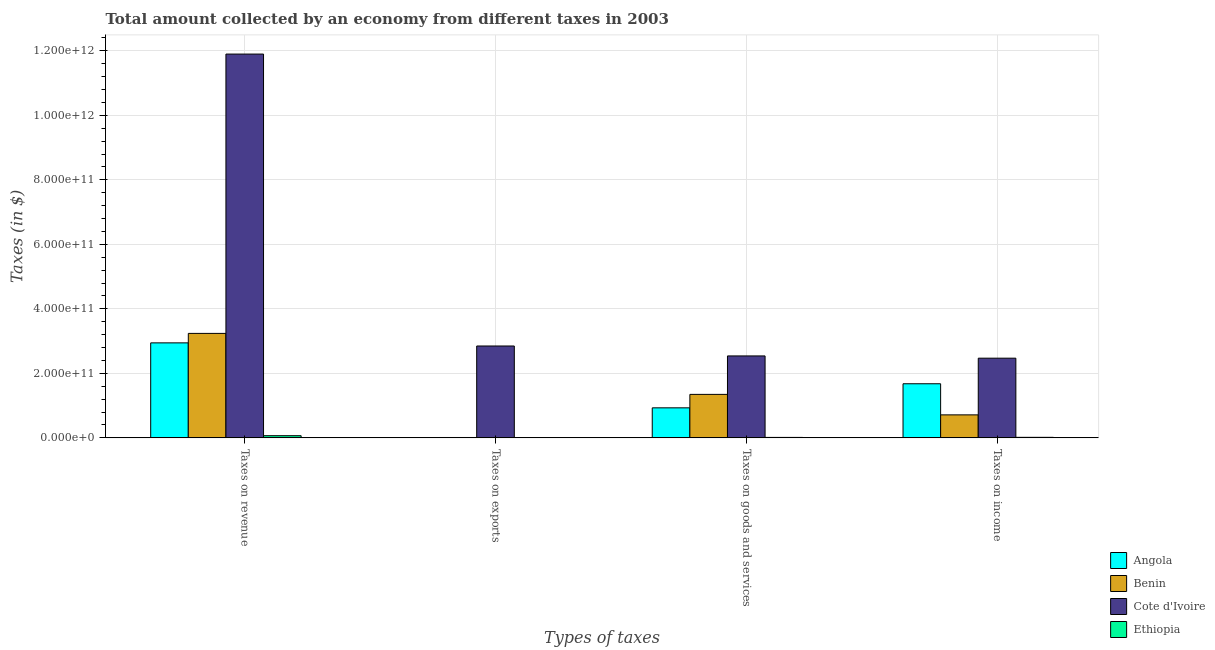Are the number of bars per tick equal to the number of legend labels?
Offer a very short reply. Yes. What is the label of the 3rd group of bars from the left?
Provide a short and direct response. Taxes on goods and services. What is the amount collected as tax on income in Angola?
Provide a succinct answer. 1.68e+11. Across all countries, what is the maximum amount collected as tax on exports?
Offer a terse response. 2.85e+11. Across all countries, what is the minimum amount collected as tax on income?
Offer a very short reply. 1.66e+09. In which country was the amount collected as tax on income maximum?
Provide a succinct answer. Cote d'Ivoire. In which country was the amount collected as tax on revenue minimum?
Keep it short and to the point. Ethiopia. What is the total amount collected as tax on goods in the graph?
Offer a terse response. 4.83e+11. What is the difference between the amount collected as tax on revenue in Angola and that in Cote d'Ivoire?
Give a very brief answer. -8.96e+11. What is the difference between the amount collected as tax on goods in Benin and the amount collected as tax on income in Cote d'Ivoire?
Make the answer very short. -1.12e+11. What is the average amount collected as tax on income per country?
Your answer should be very brief. 1.22e+11. What is the difference between the amount collected as tax on goods and amount collected as tax on income in Angola?
Offer a terse response. -7.46e+1. What is the ratio of the amount collected as tax on revenue in Benin to that in Ethiopia?
Provide a short and direct response. 48.02. Is the difference between the amount collected as tax on income in Cote d'Ivoire and Benin greater than the difference between the amount collected as tax on exports in Cote d'Ivoire and Benin?
Offer a very short reply. No. What is the difference between the highest and the second highest amount collected as tax on goods?
Make the answer very short. 1.19e+11. What is the difference between the highest and the lowest amount collected as tax on income?
Keep it short and to the point. 2.45e+11. In how many countries, is the amount collected as tax on exports greater than the average amount collected as tax on exports taken over all countries?
Your response must be concise. 1. Is it the case that in every country, the sum of the amount collected as tax on income and amount collected as tax on exports is greater than the sum of amount collected as tax on goods and amount collected as tax on revenue?
Offer a terse response. No. What does the 1st bar from the left in Taxes on goods and services represents?
Ensure brevity in your answer.  Angola. What does the 4th bar from the right in Taxes on income represents?
Provide a succinct answer. Angola. Is it the case that in every country, the sum of the amount collected as tax on revenue and amount collected as tax on exports is greater than the amount collected as tax on goods?
Ensure brevity in your answer.  Yes. How many bars are there?
Offer a terse response. 16. How many countries are there in the graph?
Make the answer very short. 4. What is the difference between two consecutive major ticks on the Y-axis?
Your response must be concise. 2.00e+11. Are the values on the major ticks of Y-axis written in scientific E-notation?
Provide a succinct answer. Yes. Does the graph contain grids?
Your response must be concise. Yes. Where does the legend appear in the graph?
Offer a very short reply. Bottom right. How are the legend labels stacked?
Give a very brief answer. Vertical. What is the title of the graph?
Your answer should be very brief. Total amount collected by an economy from different taxes in 2003. Does "Liberia" appear as one of the legend labels in the graph?
Offer a terse response. No. What is the label or title of the X-axis?
Your response must be concise. Types of taxes. What is the label or title of the Y-axis?
Your answer should be very brief. Taxes (in $). What is the Taxes (in $) of Angola in Taxes on revenue?
Make the answer very short. 2.95e+11. What is the Taxes (in $) of Benin in Taxes on revenue?
Offer a very short reply. 3.24e+11. What is the Taxes (in $) in Cote d'Ivoire in Taxes on revenue?
Your answer should be compact. 1.19e+12. What is the Taxes (in $) in Ethiopia in Taxes on revenue?
Provide a succinct answer. 6.75e+09. What is the Taxes (in $) of Angola in Taxes on exports?
Offer a terse response. 4.24e+08. What is the Taxes (in $) of Benin in Taxes on exports?
Keep it short and to the point. 1.17e+09. What is the Taxes (in $) in Cote d'Ivoire in Taxes on exports?
Offer a very short reply. 2.85e+11. What is the Taxes (in $) of Ethiopia in Taxes on exports?
Give a very brief answer. 1.10e+06. What is the Taxes (in $) of Angola in Taxes on goods and services?
Your response must be concise. 9.31e+1. What is the Taxes (in $) in Benin in Taxes on goods and services?
Your answer should be very brief. 1.35e+11. What is the Taxes (in $) of Cote d'Ivoire in Taxes on goods and services?
Make the answer very short. 2.54e+11. What is the Taxes (in $) in Ethiopia in Taxes on goods and services?
Ensure brevity in your answer.  1.40e+09. What is the Taxes (in $) of Angola in Taxes on income?
Give a very brief answer. 1.68e+11. What is the Taxes (in $) of Benin in Taxes on income?
Keep it short and to the point. 7.13e+1. What is the Taxes (in $) in Cote d'Ivoire in Taxes on income?
Your answer should be compact. 2.47e+11. What is the Taxes (in $) of Ethiopia in Taxes on income?
Provide a succinct answer. 1.66e+09. Across all Types of taxes, what is the maximum Taxes (in $) of Angola?
Your response must be concise. 2.95e+11. Across all Types of taxes, what is the maximum Taxes (in $) in Benin?
Ensure brevity in your answer.  3.24e+11. Across all Types of taxes, what is the maximum Taxes (in $) of Cote d'Ivoire?
Make the answer very short. 1.19e+12. Across all Types of taxes, what is the maximum Taxes (in $) of Ethiopia?
Give a very brief answer. 6.75e+09. Across all Types of taxes, what is the minimum Taxes (in $) of Angola?
Provide a succinct answer. 4.24e+08. Across all Types of taxes, what is the minimum Taxes (in $) of Benin?
Provide a succinct answer. 1.17e+09. Across all Types of taxes, what is the minimum Taxes (in $) of Cote d'Ivoire?
Provide a short and direct response. 2.47e+11. Across all Types of taxes, what is the minimum Taxes (in $) in Ethiopia?
Give a very brief answer. 1.10e+06. What is the total Taxes (in $) in Angola in the graph?
Your answer should be compact. 5.56e+11. What is the total Taxes (in $) of Benin in the graph?
Give a very brief answer. 5.31e+11. What is the total Taxes (in $) of Cote d'Ivoire in the graph?
Make the answer very short. 1.98e+12. What is the total Taxes (in $) in Ethiopia in the graph?
Offer a very short reply. 9.81e+09. What is the difference between the Taxes (in $) of Angola in Taxes on revenue and that in Taxes on exports?
Give a very brief answer. 2.94e+11. What is the difference between the Taxes (in $) of Benin in Taxes on revenue and that in Taxes on exports?
Your answer should be very brief. 3.23e+11. What is the difference between the Taxes (in $) in Cote d'Ivoire in Taxes on revenue and that in Taxes on exports?
Offer a very short reply. 9.05e+11. What is the difference between the Taxes (in $) in Ethiopia in Taxes on revenue and that in Taxes on exports?
Provide a succinct answer. 6.74e+09. What is the difference between the Taxes (in $) in Angola in Taxes on revenue and that in Taxes on goods and services?
Keep it short and to the point. 2.01e+11. What is the difference between the Taxes (in $) in Benin in Taxes on revenue and that in Taxes on goods and services?
Offer a very short reply. 1.89e+11. What is the difference between the Taxes (in $) in Cote d'Ivoire in Taxes on revenue and that in Taxes on goods and services?
Your answer should be compact. 9.36e+11. What is the difference between the Taxes (in $) in Ethiopia in Taxes on revenue and that in Taxes on goods and services?
Give a very brief answer. 5.35e+09. What is the difference between the Taxes (in $) in Angola in Taxes on revenue and that in Taxes on income?
Ensure brevity in your answer.  1.27e+11. What is the difference between the Taxes (in $) of Benin in Taxes on revenue and that in Taxes on income?
Your answer should be very brief. 2.53e+11. What is the difference between the Taxes (in $) of Cote d'Ivoire in Taxes on revenue and that in Taxes on income?
Your answer should be compact. 9.43e+11. What is the difference between the Taxes (in $) in Ethiopia in Taxes on revenue and that in Taxes on income?
Give a very brief answer. 5.08e+09. What is the difference between the Taxes (in $) in Angola in Taxes on exports and that in Taxes on goods and services?
Provide a succinct answer. -9.27e+1. What is the difference between the Taxes (in $) in Benin in Taxes on exports and that in Taxes on goods and services?
Keep it short and to the point. -1.34e+11. What is the difference between the Taxes (in $) of Cote d'Ivoire in Taxes on exports and that in Taxes on goods and services?
Your answer should be compact. 3.08e+1. What is the difference between the Taxes (in $) in Ethiopia in Taxes on exports and that in Taxes on goods and services?
Provide a short and direct response. -1.40e+09. What is the difference between the Taxes (in $) in Angola in Taxes on exports and that in Taxes on income?
Your response must be concise. -1.67e+11. What is the difference between the Taxes (in $) in Benin in Taxes on exports and that in Taxes on income?
Give a very brief answer. -7.01e+1. What is the difference between the Taxes (in $) of Cote d'Ivoire in Taxes on exports and that in Taxes on income?
Keep it short and to the point. 3.78e+1. What is the difference between the Taxes (in $) of Ethiopia in Taxes on exports and that in Taxes on income?
Make the answer very short. -1.66e+09. What is the difference between the Taxes (in $) in Angola in Taxes on goods and services and that in Taxes on income?
Ensure brevity in your answer.  -7.46e+1. What is the difference between the Taxes (in $) in Benin in Taxes on goods and services and that in Taxes on income?
Give a very brief answer. 6.35e+1. What is the difference between the Taxes (in $) of Cote d'Ivoire in Taxes on goods and services and that in Taxes on income?
Give a very brief answer. 7.00e+09. What is the difference between the Taxes (in $) of Ethiopia in Taxes on goods and services and that in Taxes on income?
Provide a short and direct response. -2.65e+08. What is the difference between the Taxes (in $) of Angola in Taxes on revenue and the Taxes (in $) of Benin in Taxes on exports?
Offer a terse response. 2.93e+11. What is the difference between the Taxes (in $) of Angola in Taxes on revenue and the Taxes (in $) of Cote d'Ivoire in Taxes on exports?
Make the answer very short. 9.69e+09. What is the difference between the Taxes (in $) in Angola in Taxes on revenue and the Taxes (in $) in Ethiopia in Taxes on exports?
Provide a succinct answer. 2.95e+11. What is the difference between the Taxes (in $) in Benin in Taxes on revenue and the Taxes (in $) in Cote d'Ivoire in Taxes on exports?
Your answer should be very brief. 3.90e+1. What is the difference between the Taxes (in $) of Benin in Taxes on revenue and the Taxes (in $) of Ethiopia in Taxes on exports?
Offer a terse response. 3.24e+11. What is the difference between the Taxes (in $) of Cote d'Ivoire in Taxes on revenue and the Taxes (in $) of Ethiopia in Taxes on exports?
Your response must be concise. 1.19e+12. What is the difference between the Taxes (in $) in Angola in Taxes on revenue and the Taxes (in $) in Benin in Taxes on goods and services?
Provide a short and direct response. 1.60e+11. What is the difference between the Taxes (in $) of Angola in Taxes on revenue and the Taxes (in $) of Cote d'Ivoire in Taxes on goods and services?
Your response must be concise. 4.05e+1. What is the difference between the Taxes (in $) in Angola in Taxes on revenue and the Taxes (in $) in Ethiopia in Taxes on goods and services?
Provide a short and direct response. 2.93e+11. What is the difference between the Taxes (in $) of Benin in Taxes on revenue and the Taxes (in $) of Cote d'Ivoire in Taxes on goods and services?
Give a very brief answer. 6.98e+1. What is the difference between the Taxes (in $) of Benin in Taxes on revenue and the Taxes (in $) of Ethiopia in Taxes on goods and services?
Provide a short and direct response. 3.23e+11. What is the difference between the Taxes (in $) in Cote d'Ivoire in Taxes on revenue and the Taxes (in $) in Ethiopia in Taxes on goods and services?
Offer a terse response. 1.19e+12. What is the difference between the Taxes (in $) in Angola in Taxes on revenue and the Taxes (in $) in Benin in Taxes on income?
Ensure brevity in your answer.  2.23e+11. What is the difference between the Taxes (in $) in Angola in Taxes on revenue and the Taxes (in $) in Cote d'Ivoire in Taxes on income?
Make the answer very short. 4.75e+1. What is the difference between the Taxes (in $) in Angola in Taxes on revenue and the Taxes (in $) in Ethiopia in Taxes on income?
Offer a very short reply. 2.93e+11. What is the difference between the Taxes (in $) in Benin in Taxes on revenue and the Taxes (in $) in Cote d'Ivoire in Taxes on income?
Provide a short and direct response. 7.68e+1. What is the difference between the Taxes (in $) of Benin in Taxes on revenue and the Taxes (in $) of Ethiopia in Taxes on income?
Provide a succinct answer. 3.22e+11. What is the difference between the Taxes (in $) of Cote d'Ivoire in Taxes on revenue and the Taxes (in $) of Ethiopia in Taxes on income?
Offer a very short reply. 1.19e+12. What is the difference between the Taxes (in $) in Angola in Taxes on exports and the Taxes (in $) in Benin in Taxes on goods and services?
Offer a terse response. -1.34e+11. What is the difference between the Taxes (in $) of Angola in Taxes on exports and the Taxes (in $) of Cote d'Ivoire in Taxes on goods and services?
Provide a succinct answer. -2.54e+11. What is the difference between the Taxes (in $) of Angola in Taxes on exports and the Taxes (in $) of Ethiopia in Taxes on goods and services?
Ensure brevity in your answer.  -9.74e+08. What is the difference between the Taxes (in $) of Benin in Taxes on exports and the Taxes (in $) of Cote d'Ivoire in Taxes on goods and services?
Ensure brevity in your answer.  -2.53e+11. What is the difference between the Taxes (in $) of Benin in Taxes on exports and the Taxes (in $) of Ethiopia in Taxes on goods and services?
Offer a terse response. -2.24e+08. What is the difference between the Taxes (in $) of Cote d'Ivoire in Taxes on exports and the Taxes (in $) of Ethiopia in Taxes on goods and services?
Your response must be concise. 2.84e+11. What is the difference between the Taxes (in $) in Angola in Taxes on exports and the Taxes (in $) in Benin in Taxes on income?
Your answer should be very brief. -7.09e+1. What is the difference between the Taxes (in $) in Angola in Taxes on exports and the Taxes (in $) in Cote d'Ivoire in Taxes on income?
Provide a short and direct response. -2.47e+11. What is the difference between the Taxes (in $) of Angola in Taxes on exports and the Taxes (in $) of Ethiopia in Taxes on income?
Make the answer very short. -1.24e+09. What is the difference between the Taxes (in $) in Benin in Taxes on exports and the Taxes (in $) in Cote d'Ivoire in Taxes on income?
Ensure brevity in your answer.  -2.46e+11. What is the difference between the Taxes (in $) of Benin in Taxes on exports and the Taxes (in $) of Ethiopia in Taxes on income?
Your answer should be very brief. -4.90e+08. What is the difference between the Taxes (in $) in Cote d'Ivoire in Taxes on exports and the Taxes (in $) in Ethiopia in Taxes on income?
Your answer should be very brief. 2.83e+11. What is the difference between the Taxes (in $) in Angola in Taxes on goods and services and the Taxes (in $) in Benin in Taxes on income?
Your answer should be compact. 2.18e+1. What is the difference between the Taxes (in $) in Angola in Taxes on goods and services and the Taxes (in $) in Cote d'Ivoire in Taxes on income?
Your answer should be compact. -1.54e+11. What is the difference between the Taxes (in $) of Angola in Taxes on goods and services and the Taxes (in $) of Ethiopia in Taxes on income?
Offer a terse response. 9.15e+1. What is the difference between the Taxes (in $) of Benin in Taxes on goods and services and the Taxes (in $) of Cote d'Ivoire in Taxes on income?
Your answer should be very brief. -1.12e+11. What is the difference between the Taxes (in $) of Benin in Taxes on goods and services and the Taxes (in $) of Ethiopia in Taxes on income?
Provide a succinct answer. 1.33e+11. What is the difference between the Taxes (in $) of Cote d'Ivoire in Taxes on goods and services and the Taxes (in $) of Ethiopia in Taxes on income?
Provide a succinct answer. 2.52e+11. What is the average Taxes (in $) of Angola per Types of taxes?
Your answer should be compact. 1.39e+11. What is the average Taxes (in $) in Benin per Types of taxes?
Ensure brevity in your answer.  1.33e+11. What is the average Taxes (in $) in Cote d'Ivoire per Types of taxes?
Your response must be concise. 4.94e+11. What is the average Taxes (in $) in Ethiopia per Types of taxes?
Your answer should be very brief. 2.45e+09. What is the difference between the Taxes (in $) of Angola and Taxes (in $) of Benin in Taxes on revenue?
Your answer should be compact. -2.93e+1. What is the difference between the Taxes (in $) of Angola and Taxes (in $) of Cote d'Ivoire in Taxes on revenue?
Provide a short and direct response. -8.96e+11. What is the difference between the Taxes (in $) of Angola and Taxes (in $) of Ethiopia in Taxes on revenue?
Offer a very short reply. 2.88e+11. What is the difference between the Taxes (in $) in Benin and Taxes (in $) in Cote d'Ivoire in Taxes on revenue?
Your response must be concise. -8.66e+11. What is the difference between the Taxes (in $) in Benin and Taxes (in $) in Ethiopia in Taxes on revenue?
Ensure brevity in your answer.  3.17e+11. What is the difference between the Taxes (in $) in Cote d'Ivoire and Taxes (in $) in Ethiopia in Taxes on revenue?
Make the answer very short. 1.18e+12. What is the difference between the Taxes (in $) in Angola and Taxes (in $) in Benin in Taxes on exports?
Your response must be concise. -7.50e+08. What is the difference between the Taxes (in $) of Angola and Taxes (in $) of Cote d'Ivoire in Taxes on exports?
Ensure brevity in your answer.  -2.84e+11. What is the difference between the Taxes (in $) of Angola and Taxes (in $) of Ethiopia in Taxes on exports?
Give a very brief answer. 4.22e+08. What is the difference between the Taxes (in $) in Benin and Taxes (in $) in Cote d'Ivoire in Taxes on exports?
Your answer should be compact. -2.84e+11. What is the difference between the Taxes (in $) of Benin and Taxes (in $) of Ethiopia in Taxes on exports?
Provide a succinct answer. 1.17e+09. What is the difference between the Taxes (in $) of Cote d'Ivoire and Taxes (in $) of Ethiopia in Taxes on exports?
Give a very brief answer. 2.85e+11. What is the difference between the Taxes (in $) of Angola and Taxes (in $) of Benin in Taxes on goods and services?
Your answer should be very brief. -4.17e+1. What is the difference between the Taxes (in $) of Angola and Taxes (in $) of Cote d'Ivoire in Taxes on goods and services?
Your answer should be compact. -1.61e+11. What is the difference between the Taxes (in $) in Angola and Taxes (in $) in Ethiopia in Taxes on goods and services?
Your answer should be compact. 9.17e+1. What is the difference between the Taxes (in $) in Benin and Taxes (in $) in Cote d'Ivoire in Taxes on goods and services?
Ensure brevity in your answer.  -1.19e+11. What is the difference between the Taxes (in $) of Benin and Taxes (in $) of Ethiopia in Taxes on goods and services?
Keep it short and to the point. 1.33e+11. What is the difference between the Taxes (in $) in Cote d'Ivoire and Taxes (in $) in Ethiopia in Taxes on goods and services?
Make the answer very short. 2.53e+11. What is the difference between the Taxes (in $) of Angola and Taxes (in $) of Benin in Taxes on income?
Make the answer very short. 9.65e+1. What is the difference between the Taxes (in $) of Angola and Taxes (in $) of Cote d'Ivoire in Taxes on income?
Offer a terse response. -7.93e+1. What is the difference between the Taxes (in $) in Angola and Taxes (in $) in Ethiopia in Taxes on income?
Give a very brief answer. 1.66e+11. What is the difference between the Taxes (in $) in Benin and Taxes (in $) in Cote d'Ivoire in Taxes on income?
Your response must be concise. -1.76e+11. What is the difference between the Taxes (in $) in Benin and Taxes (in $) in Ethiopia in Taxes on income?
Provide a short and direct response. 6.96e+1. What is the difference between the Taxes (in $) of Cote d'Ivoire and Taxes (in $) of Ethiopia in Taxes on income?
Provide a succinct answer. 2.45e+11. What is the ratio of the Taxes (in $) of Angola in Taxes on revenue to that in Taxes on exports?
Your answer should be compact. 695.46. What is the ratio of the Taxes (in $) of Benin in Taxes on revenue to that in Taxes on exports?
Offer a terse response. 276.11. What is the ratio of the Taxes (in $) of Cote d'Ivoire in Taxes on revenue to that in Taxes on exports?
Offer a very short reply. 4.18. What is the ratio of the Taxes (in $) of Ethiopia in Taxes on revenue to that in Taxes on exports?
Your answer should be very brief. 6132.82. What is the ratio of the Taxes (in $) in Angola in Taxes on revenue to that in Taxes on goods and services?
Ensure brevity in your answer.  3.16. What is the ratio of the Taxes (in $) in Benin in Taxes on revenue to that in Taxes on goods and services?
Offer a very short reply. 2.4. What is the ratio of the Taxes (in $) of Cote d'Ivoire in Taxes on revenue to that in Taxes on goods and services?
Provide a short and direct response. 4.68. What is the ratio of the Taxes (in $) in Ethiopia in Taxes on revenue to that in Taxes on goods and services?
Offer a terse response. 4.83. What is the ratio of the Taxes (in $) of Angola in Taxes on revenue to that in Taxes on income?
Your response must be concise. 1.76. What is the ratio of the Taxes (in $) in Benin in Taxes on revenue to that in Taxes on income?
Your answer should be very brief. 4.54. What is the ratio of the Taxes (in $) of Cote d'Ivoire in Taxes on revenue to that in Taxes on income?
Keep it short and to the point. 4.82. What is the ratio of the Taxes (in $) of Ethiopia in Taxes on revenue to that in Taxes on income?
Offer a terse response. 4.06. What is the ratio of the Taxes (in $) in Angola in Taxes on exports to that in Taxes on goods and services?
Give a very brief answer. 0. What is the ratio of the Taxes (in $) in Benin in Taxes on exports to that in Taxes on goods and services?
Make the answer very short. 0.01. What is the ratio of the Taxes (in $) of Cote d'Ivoire in Taxes on exports to that in Taxes on goods and services?
Offer a terse response. 1.12. What is the ratio of the Taxes (in $) of Ethiopia in Taxes on exports to that in Taxes on goods and services?
Keep it short and to the point. 0. What is the ratio of the Taxes (in $) of Angola in Taxes on exports to that in Taxes on income?
Ensure brevity in your answer.  0. What is the ratio of the Taxes (in $) of Benin in Taxes on exports to that in Taxes on income?
Your answer should be very brief. 0.02. What is the ratio of the Taxes (in $) in Cote d'Ivoire in Taxes on exports to that in Taxes on income?
Offer a terse response. 1.15. What is the ratio of the Taxes (in $) in Ethiopia in Taxes on exports to that in Taxes on income?
Your answer should be very brief. 0. What is the ratio of the Taxes (in $) of Angola in Taxes on goods and services to that in Taxes on income?
Your answer should be compact. 0.56. What is the ratio of the Taxes (in $) of Benin in Taxes on goods and services to that in Taxes on income?
Provide a short and direct response. 1.89. What is the ratio of the Taxes (in $) of Cote d'Ivoire in Taxes on goods and services to that in Taxes on income?
Offer a very short reply. 1.03. What is the ratio of the Taxes (in $) of Ethiopia in Taxes on goods and services to that in Taxes on income?
Ensure brevity in your answer.  0.84. What is the difference between the highest and the second highest Taxes (in $) in Angola?
Offer a terse response. 1.27e+11. What is the difference between the highest and the second highest Taxes (in $) of Benin?
Offer a terse response. 1.89e+11. What is the difference between the highest and the second highest Taxes (in $) in Cote d'Ivoire?
Your response must be concise. 9.05e+11. What is the difference between the highest and the second highest Taxes (in $) in Ethiopia?
Your response must be concise. 5.08e+09. What is the difference between the highest and the lowest Taxes (in $) of Angola?
Give a very brief answer. 2.94e+11. What is the difference between the highest and the lowest Taxes (in $) in Benin?
Your answer should be very brief. 3.23e+11. What is the difference between the highest and the lowest Taxes (in $) of Cote d'Ivoire?
Your answer should be very brief. 9.43e+11. What is the difference between the highest and the lowest Taxes (in $) of Ethiopia?
Ensure brevity in your answer.  6.74e+09. 